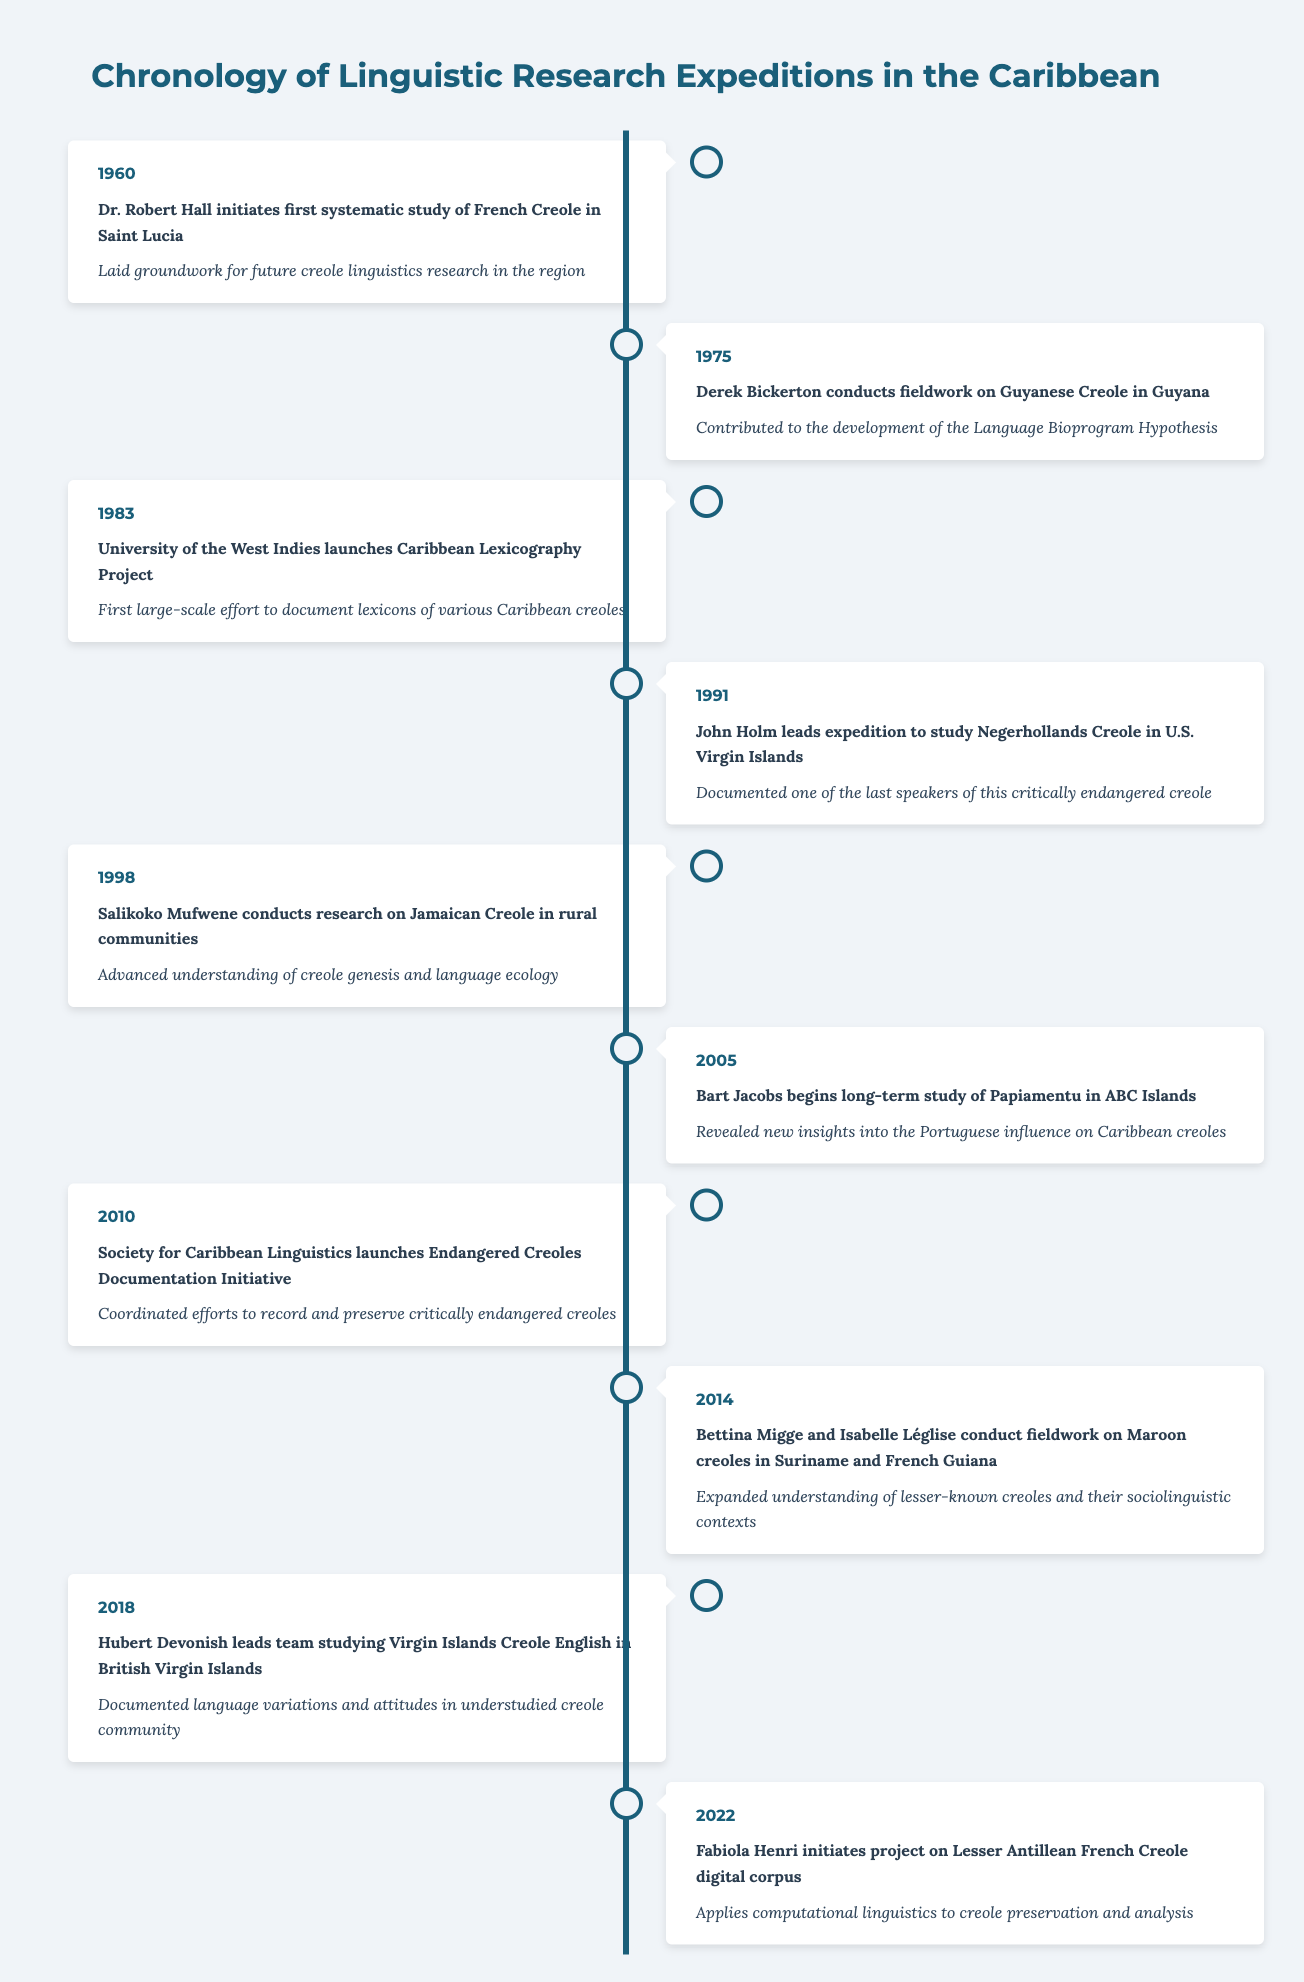What year did Dr. Robert Hall initiate the first systematic study of French Creole? The table states that Dr. Robert Hall initiated the first systematic study of French Creole in Saint Lucia in the year 1960.
Answer: 1960 What significant contribution did Derek Bickerton make in 1975? According to the table, Derek Bickerton conducted fieldwork on Guyanese Creole in Guyana in 1975 and this contributed to the development of the Language Bioprogram Hypothesis.
Answer: Contributed to the development of the Language Bioprogram Hypothesis In which year was the Caribbean Lexicography Project launched? The table indicates that the University of the West Indies launched the Caribbean Lexicography Project in 1983.
Answer: 1983 How many research expeditions occurred before the year 2000? From the table, there are five research expeditions mentioned before the year 2000: 1960, 1975, 1983, 1991, and 1998. Therefore, the total count is five.
Answer: 5 Did Fabiola Henri's project focus on a digital corpus for Lesser Antillean French Creole? According to the table, Fabiola Henri initiated a project specifically on a digital corpus for Lesser Antillean French Creole in 2022. Thus, the statement is true.
Answer: Yes What is the significance of the research conducted by John Holm in 1991? The significance of John Holm's expedition to study Negerhollands Creole in 1991, as noted in the table, is that he documented one of the last speakers of this critically endangered creole.
Answer: Documented one of the last speakers of this critically endangered creole From the events listed, how many research studies were focused on Jamaican Creole? The table shows that only one research study specifically focused on Jamaican Creole, conducted by Salikoko Mufwene in 1998.
Answer: 1 What was the common theme of research between 2010 and 2022? Both events during this period aimed at preserving endangered creoles; the 2010 initiative focused on coordinating efforts to record endangered creoles while the 2022 project used computational linguistics for preservation.
Answer: Preservation of endangered creoles Which researcher contributed to understanding the Portuguese influence on Caribbean creoles? The table states that Bart Jacobs began the long-term study of Papiamentu in the ABC Islands in 2005, revealing new insights into the Portuguese influence on Caribbean creoles.
Answer: Bart Jacobs 